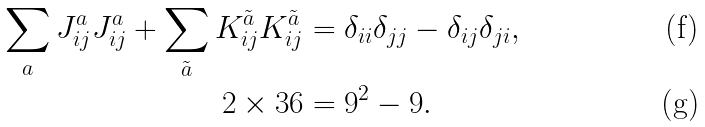Convert formula to latex. <formula><loc_0><loc_0><loc_500><loc_500>\sum _ { a } J ^ { a } _ { i j } J ^ { a } _ { i j } + \sum _ { \tilde { a } } K ^ { \tilde { a } } _ { i j } K ^ { \tilde { a } } _ { i j } & = \delta _ { i i } \delta _ { j j } - \delta _ { i j } \delta _ { j i } , \\ 2 \times 3 6 & = 9 ^ { 2 } - 9 .</formula> 